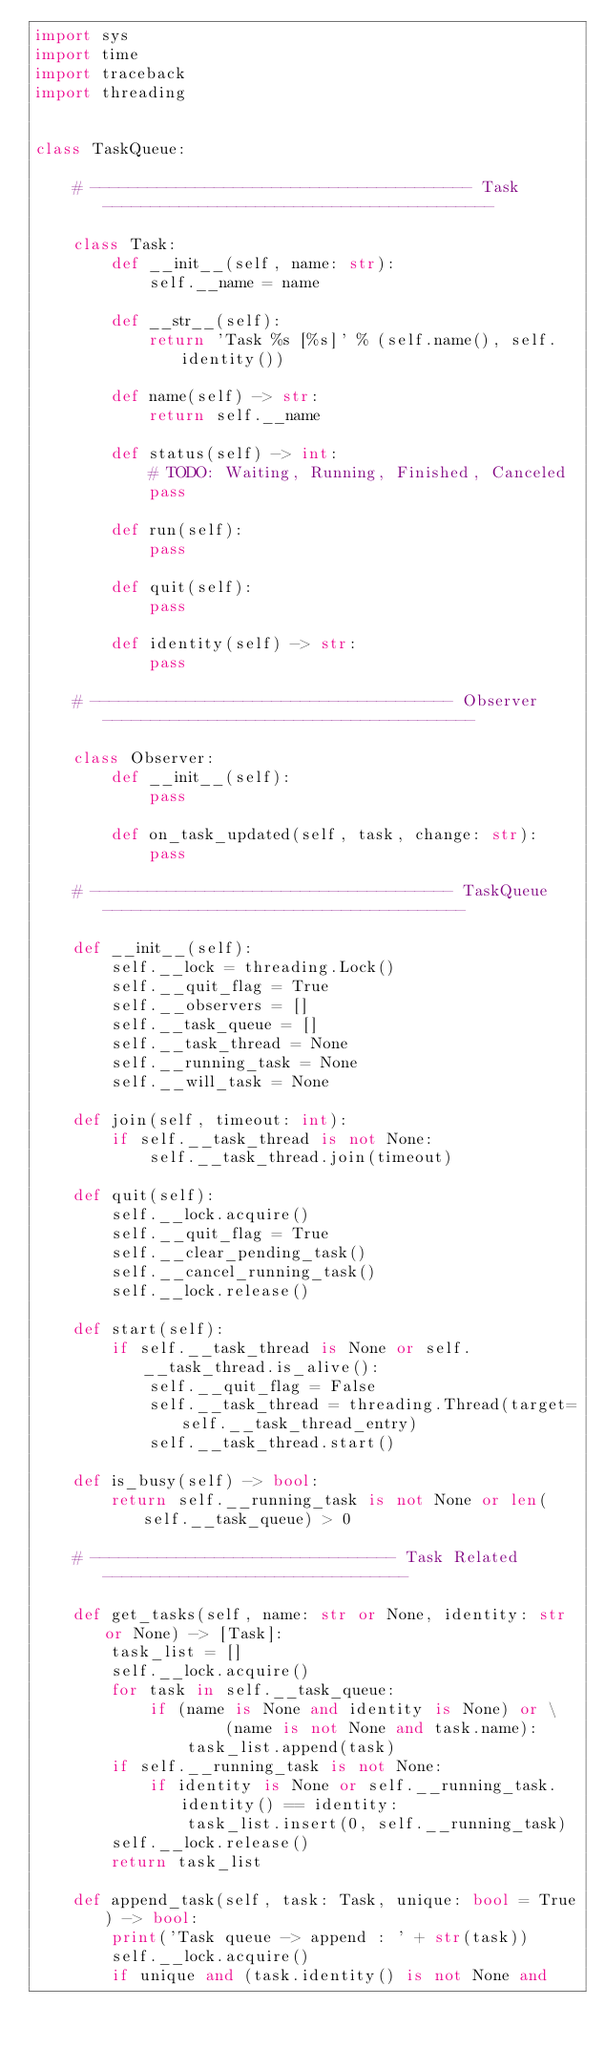Convert code to text. <code><loc_0><loc_0><loc_500><loc_500><_Python_>import sys
import time
import traceback
import threading


class TaskQueue:

    # ---------------------------------------- Task -----------------------------------------

    class Task:
        def __init__(self, name: str):
            self.__name = name

        def __str__(self):
            return 'Task %s [%s]' % (self.name(), self.identity())

        def name(self) -> str:
            return self.__name

        def status(self) -> int:
            # TODO: Waiting, Running, Finished, Canceled
            pass

        def run(self):
            pass

        def quit(self):
            pass

        def identity(self) -> str:
            pass

    # -------------------------------------- Observer ---------------------------------------

    class Observer:
        def __init__(self):
            pass

        def on_task_updated(self, task, change: str):
            pass

    # -------------------------------------- TaskQueue --------------------------------------

    def __init__(self):
        self.__lock = threading.Lock()
        self.__quit_flag = True
        self.__observers = []
        self.__task_queue = []
        self.__task_thread = None
        self.__running_task = None
        self.__will_task = None

    def join(self, timeout: int):
        if self.__task_thread is not None:
            self.__task_thread.join(timeout)

    def quit(self):
        self.__lock.acquire()
        self.__quit_flag = True
        self.__clear_pending_task()
        self.__cancel_running_task()
        self.__lock.release()

    def start(self):
        if self.__task_thread is None or self.__task_thread.is_alive():
            self.__quit_flag = False
            self.__task_thread = threading.Thread(target=self.__task_thread_entry)
            self.__task_thread.start()

    def is_busy(self) -> bool:
        return self.__running_task is not None or len(self.__task_queue) > 0

    # -------------------------------- Task Related --------------------------------

    def get_tasks(self, name: str or None, identity: str or None) -> [Task]:
        task_list = []
        self.__lock.acquire()
        for task in self.__task_queue:
            if (name is None and identity is None) or \
                    (name is not None and task.name):
                task_list.append(task)
        if self.__running_task is not None:
            if identity is None or self.__running_task.identity() == identity:
                task_list.insert(0, self.__running_task)
        self.__lock.release()
        return task_list

    def append_task(self, task: Task, unique: bool = True) -> bool:
        print('Task queue -> append : ' + str(task))
        self.__lock.acquire()
        if unique and (task.identity() is not None and</code> 